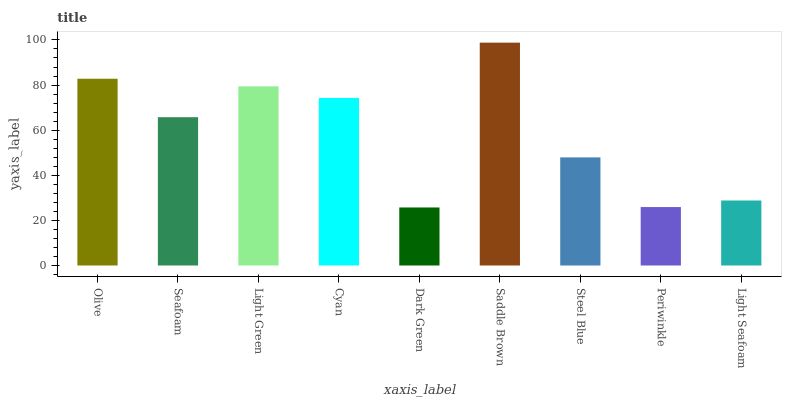Is Dark Green the minimum?
Answer yes or no. Yes. Is Saddle Brown the maximum?
Answer yes or no. Yes. Is Seafoam the minimum?
Answer yes or no. No. Is Seafoam the maximum?
Answer yes or no. No. Is Olive greater than Seafoam?
Answer yes or no. Yes. Is Seafoam less than Olive?
Answer yes or no. Yes. Is Seafoam greater than Olive?
Answer yes or no. No. Is Olive less than Seafoam?
Answer yes or no. No. Is Seafoam the high median?
Answer yes or no. Yes. Is Seafoam the low median?
Answer yes or no. Yes. Is Olive the high median?
Answer yes or no. No. Is Olive the low median?
Answer yes or no. No. 